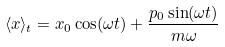<formula> <loc_0><loc_0><loc_500><loc_500>\langle x \rangle _ { t } = x _ { 0 } \cos ( \omega t ) + \frac { p _ { 0 } \sin ( \omega t ) } { m \omega }</formula> 